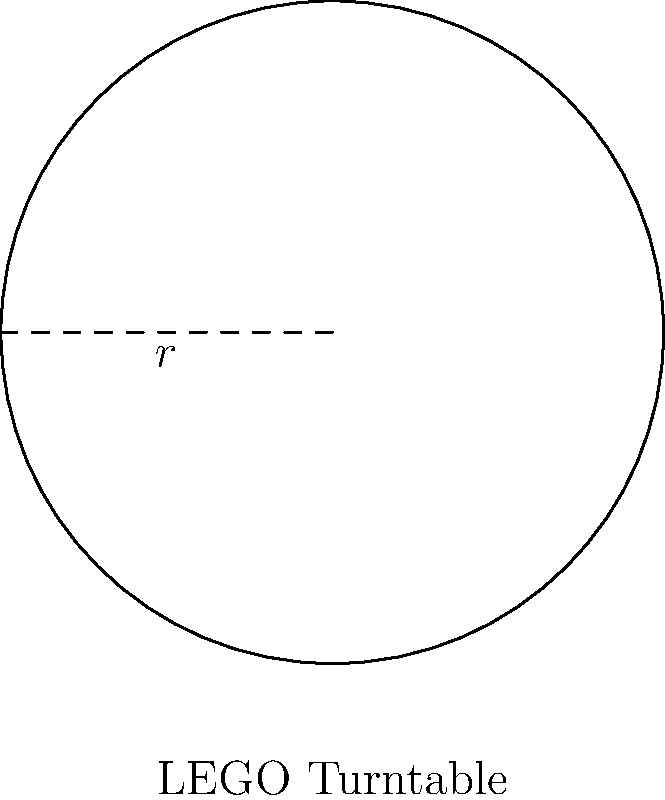Super Builder, you've just received a special LEGO turntable piece! It's a perfect circle with a radius of 4 studs. Can you calculate the area of this awesome turntable in square studs? Great question, little hero! Let's solve this step-by-step:

1) We know that the turntable is a circle, and we have its radius.
2) The formula for the area of a circle is $A = \pi r^2$, where $r$ is the radius.
3) We're given that the radius is 4 studs.
4) Let's plug this into our formula:
   $A = \pi \cdot 4^2$
5) First, let's calculate $4^2$:
   $A = \pi \cdot 16$
6) Now, let's multiply by $\pi$:
   $A = 16\pi$ square studs

7) If we want to give a decimal approximation, we can use $\pi \approx 3.14159$:
   $A \approx 16 \cdot 3.14159 \approx 50.27$ square studs

So, the area of your special LEGO turntable is exactly $16\pi$ square studs, or approximately 50.27 square studs.
Answer: $16\pi$ square studs 